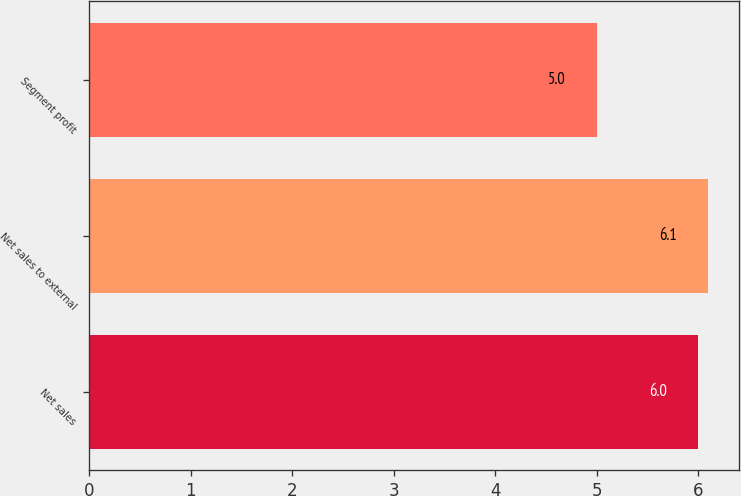<chart> <loc_0><loc_0><loc_500><loc_500><bar_chart><fcel>Net sales<fcel>Net sales to external<fcel>Segment profit<nl><fcel>6<fcel>6.1<fcel>5<nl></chart> 